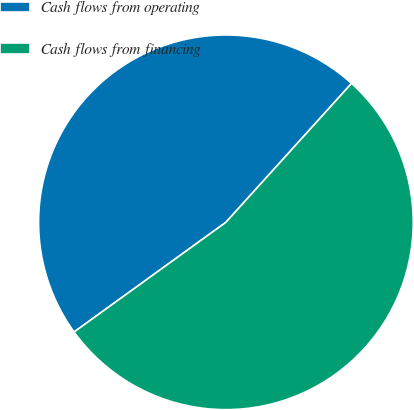Convert chart to OTSL. <chart><loc_0><loc_0><loc_500><loc_500><pie_chart><fcel>Cash flows from operating<fcel>Cash flows from financing<nl><fcel>46.66%<fcel>53.34%<nl></chart> 